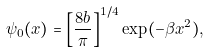<formula> <loc_0><loc_0><loc_500><loc_500>\psi _ { 0 } ( x ) = \left [ \frac { 8 b } { \pi } \right ] ^ { 1 / 4 } \exp ( - \beta x ^ { 2 } ) ,</formula> 